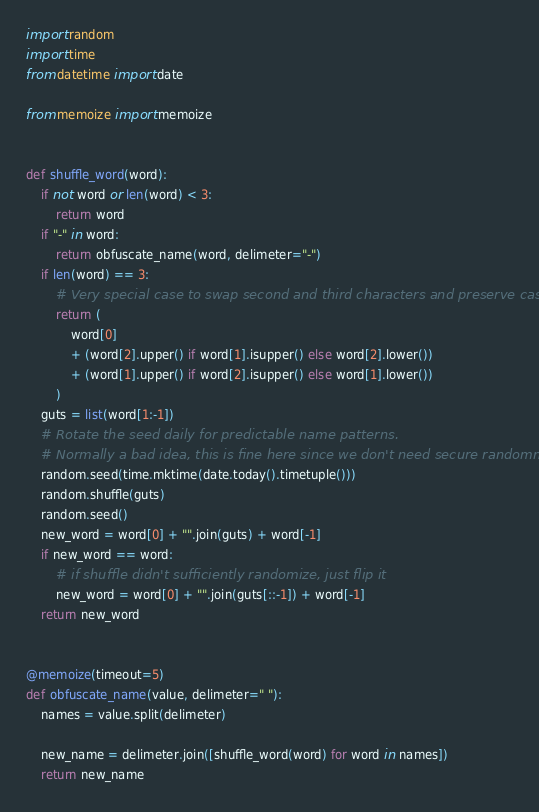Convert code to text. <code><loc_0><loc_0><loc_500><loc_500><_Python_>import random
import time
from datetime import date

from memoize import memoize


def shuffle_word(word):
    if not word or len(word) < 3:
        return word
    if "-" in word:
        return obfuscate_name(word, delimeter="-")
    if len(word) == 3:
        # Very special case to swap second and third characters and preserve case.
        return (
            word[0]
            + (word[2].upper() if word[1].isupper() else word[2].lower())
            + (word[1].upper() if word[2].isupper() else word[1].lower())
        )
    guts = list(word[1:-1])
    # Rotate the seed daily for predictable name patterns.
    # Normally a bad idea, this is fine here since we don't need secure randomness.
    random.seed(time.mktime(date.today().timetuple()))
    random.shuffle(guts)
    random.seed()
    new_word = word[0] + "".join(guts) + word[-1]
    if new_word == word:
        # if shuffle didn't sufficiently randomize, just flip it
        new_word = word[0] + "".join(guts[::-1]) + word[-1]
    return new_word


@memoize(timeout=5)
def obfuscate_name(value, delimeter=" "):
    names = value.split(delimeter)

    new_name = delimeter.join([shuffle_word(word) for word in names])
    return new_name
</code> 